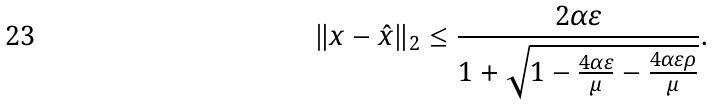Convert formula to latex. <formula><loc_0><loc_0><loc_500><loc_500>\| x - \hat { x } \| _ { 2 } \leq \frac { 2 \alpha \varepsilon } { 1 + \sqrt { 1 - \frac { 4 \alpha \varepsilon } { \mu } - \frac { 4 \alpha \varepsilon \rho } { \mu } } } .</formula> 